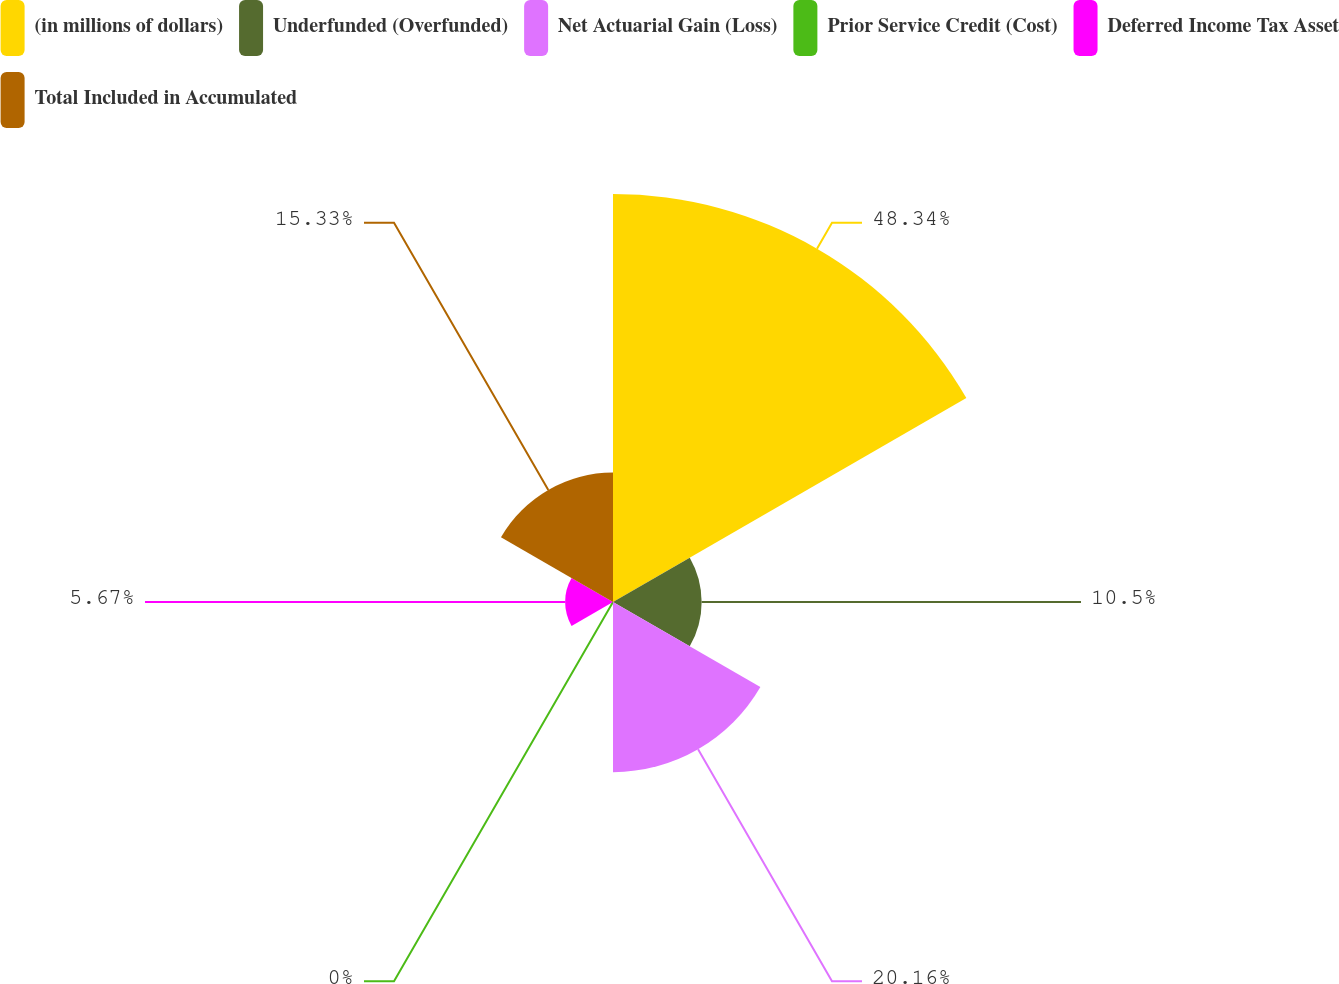<chart> <loc_0><loc_0><loc_500><loc_500><pie_chart><fcel>(in millions of dollars)<fcel>Underfunded (Overfunded)<fcel>Net Actuarial Gain (Loss)<fcel>Prior Service Credit (Cost)<fcel>Deferred Income Tax Asset<fcel>Total Included in Accumulated<nl><fcel>48.34%<fcel>10.5%<fcel>20.16%<fcel>0.0%<fcel>5.67%<fcel>15.33%<nl></chart> 